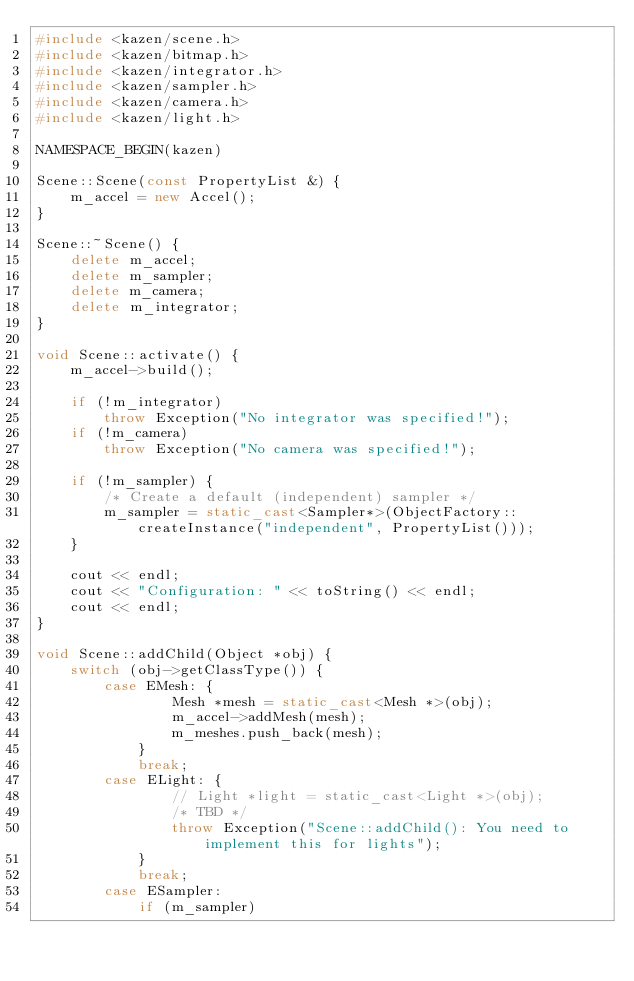<code> <loc_0><loc_0><loc_500><loc_500><_C++_>#include <kazen/scene.h>
#include <kazen/bitmap.h>
#include <kazen/integrator.h>
#include <kazen/sampler.h>
#include <kazen/camera.h>
#include <kazen/light.h>

NAMESPACE_BEGIN(kazen)

Scene::Scene(const PropertyList &) {
    m_accel = new Accel();
}

Scene::~Scene() {
    delete m_accel;
    delete m_sampler;
    delete m_camera;
    delete m_integrator;
}

void Scene::activate() {
    m_accel->build();

    if (!m_integrator)
        throw Exception("No integrator was specified!");
    if (!m_camera)
        throw Exception("No camera was specified!");
    
    if (!m_sampler) {
        /* Create a default (independent) sampler */
        m_sampler = static_cast<Sampler*>(ObjectFactory::createInstance("independent", PropertyList()));
    }

    cout << endl;
    cout << "Configuration: " << toString() << endl;
    cout << endl;
}

void Scene::addChild(Object *obj) {
    switch (obj->getClassType()) {
        case EMesh: {
                Mesh *mesh = static_cast<Mesh *>(obj);
                m_accel->addMesh(mesh);
                m_meshes.push_back(mesh);
            }
            break;
        case ELight: {
                // Light *light = static_cast<Light *>(obj);
                /* TBD */
                throw Exception("Scene::addChild(): You need to implement this for lights");
            }
            break;
        case ESampler:
            if (m_sampler)</code> 